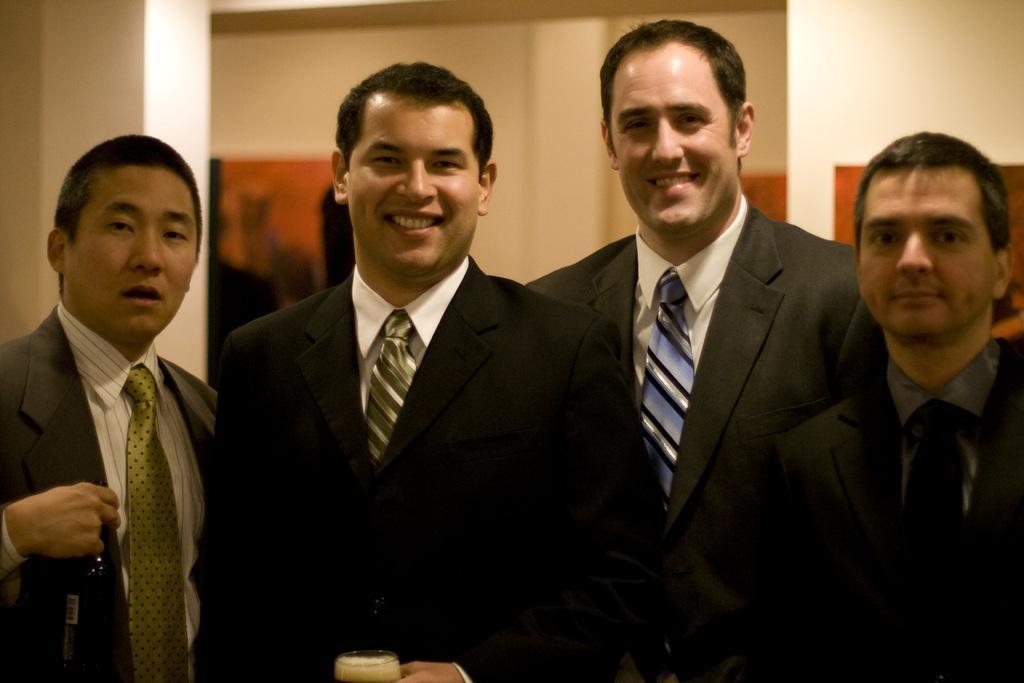Can you describe this image briefly? in this image I can see four men wearing suit and tie. I can see two smiley faces also one man is holding a cup. 